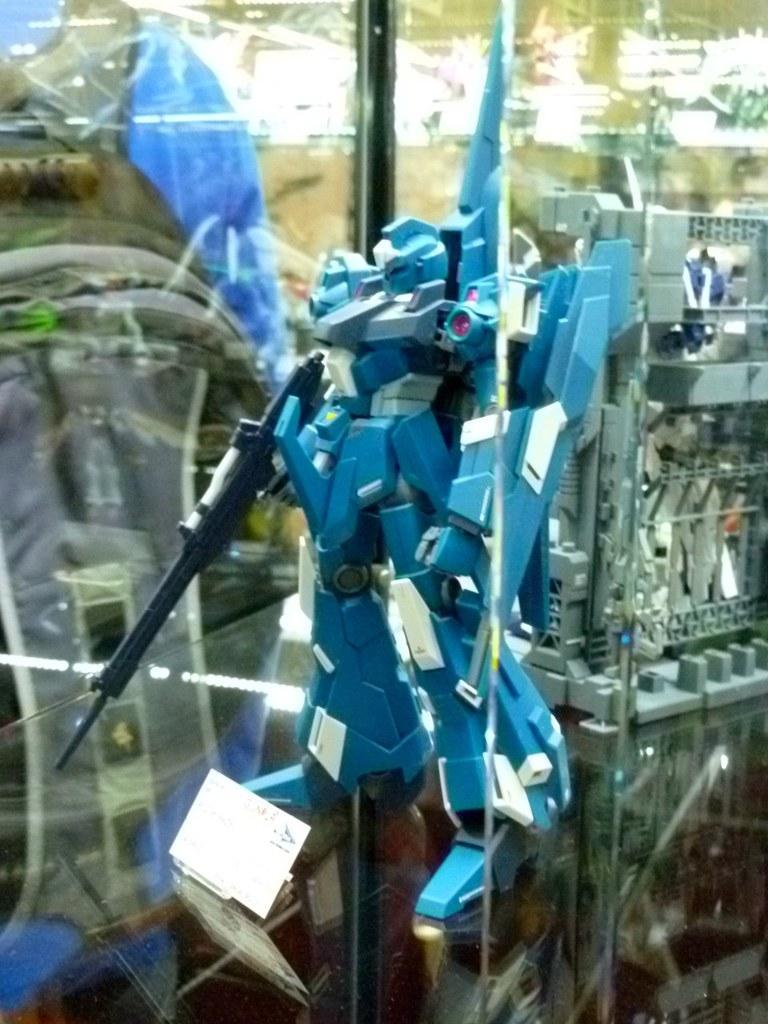Could you give a brief overview of what you see in this image? In this image we can see a robot. In the background we can see the glass window and through the glass window we can see some person wearing the bag. We can also see some other objects. 